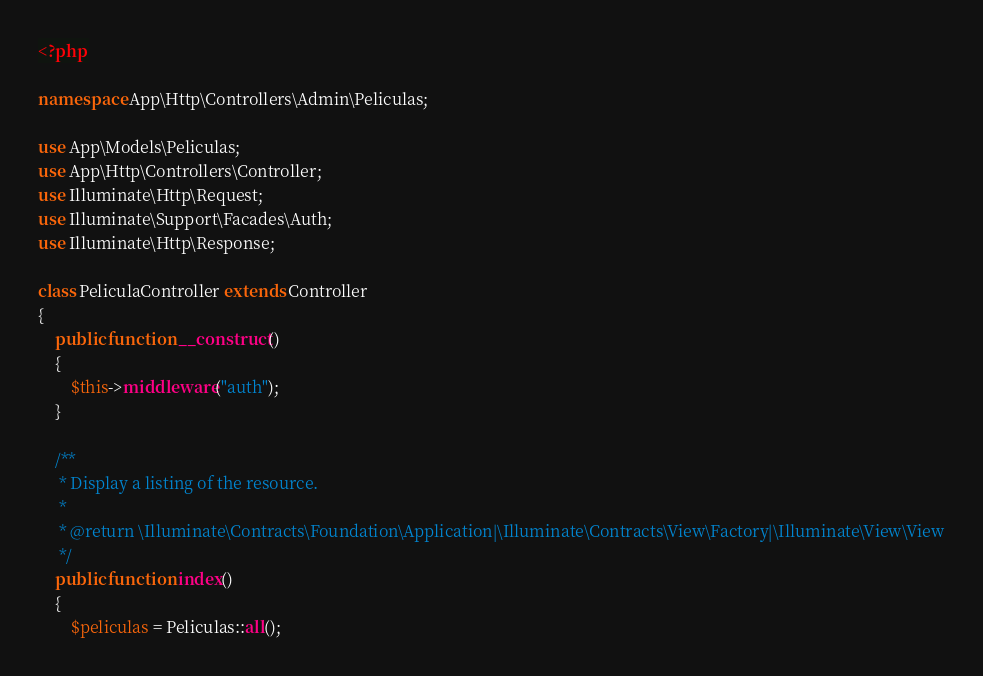<code> <loc_0><loc_0><loc_500><loc_500><_PHP_><?php

namespace App\Http\Controllers\Admin\Peliculas;

use App\Models\Peliculas;
use App\Http\Controllers\Controller;
use Illuminate\Http\Request;
use Illuminate\Support\Facades\Auth;
use Illuminate\Http\Response;

class PeliculaController extends Controller
{
    public function __construct()
    {
        $this->middleware("auth");
    }

    /**
     * Display a listing of the resource.
     *
     * @return \Illuminate\Contracts\Foundation\Application|\Illuminate\Contracts\View\Factory|\Illuminate\View\View
     */
    public function index()
    {
        $peliculas = Peliculas::all();</code> 